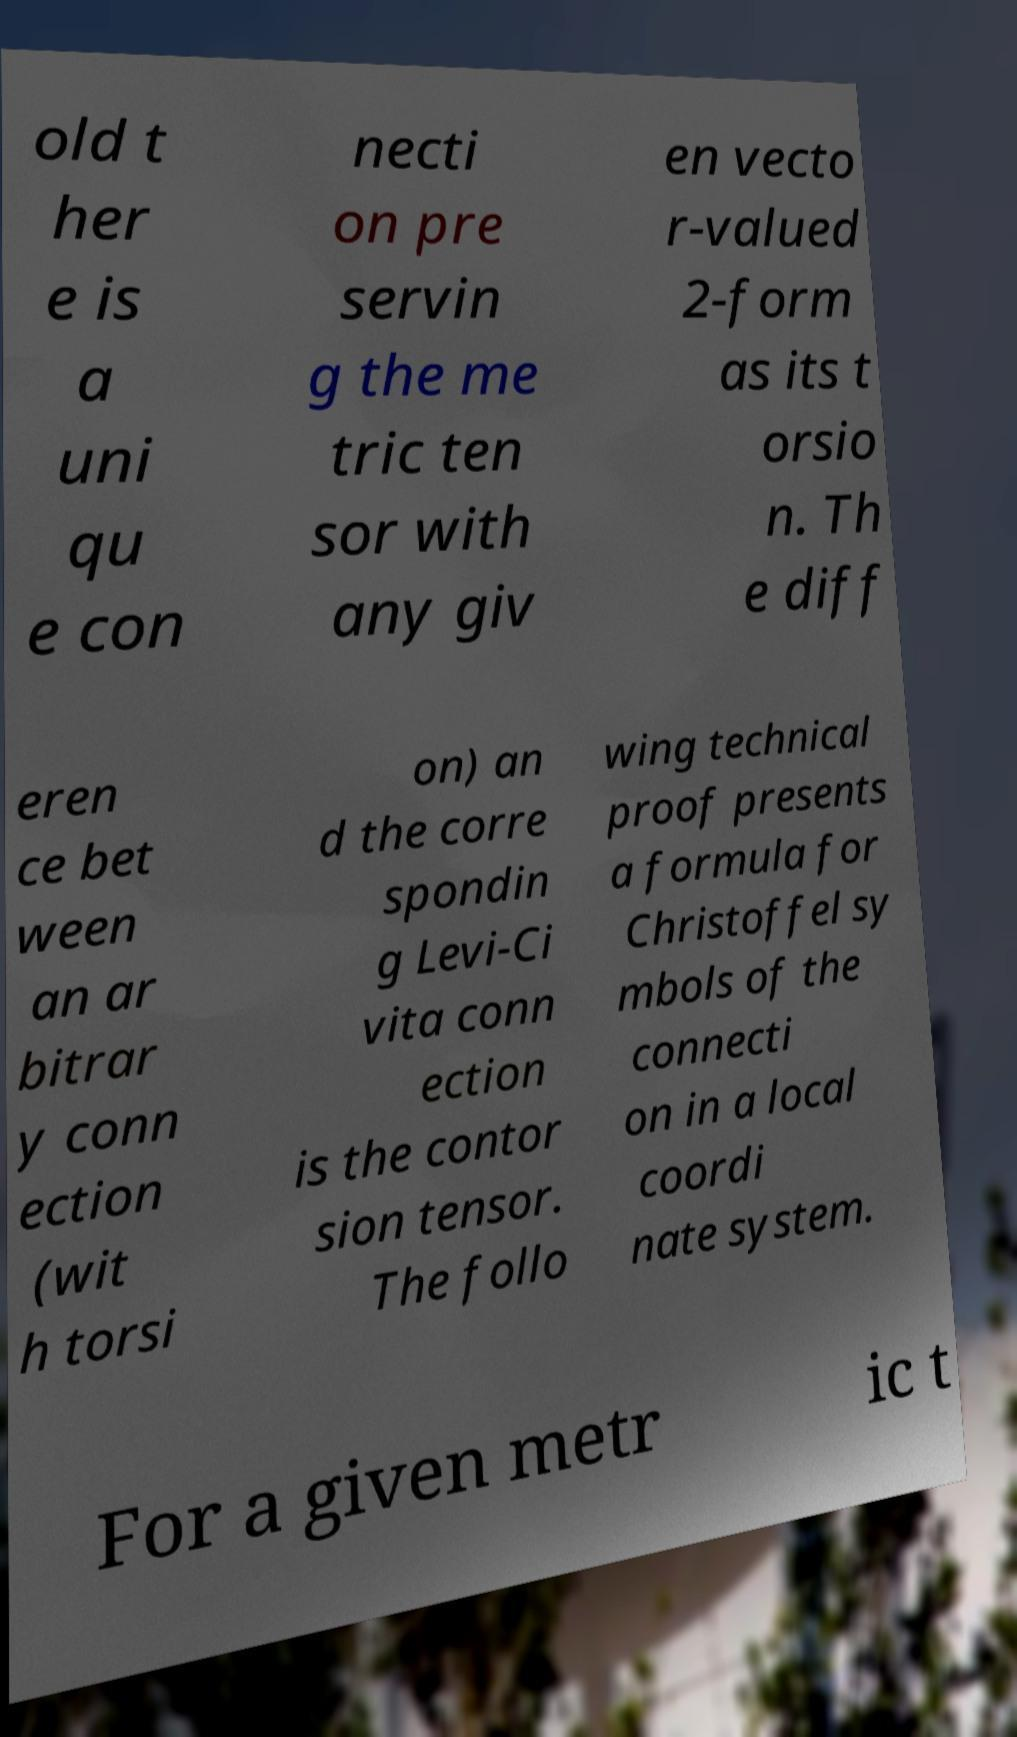Could you assist in decoding the text presented in this image and type it out clearly? old t her e is a uni qu e con necti on pre servin g the me tric ten sor with any giv en vecto r-valued 2-form as its t orsio n. Th e diff eren ce bet ween an ar bitrar y conn ection (wit h torsi on) an d the corre spondin g Levi-Ci vita conn ection is the contor sion tensor. The follo wing technical proof presents a formula for Christoffel sy mbols of the connecti on in a local coordi nate system. For a given metr ic t 